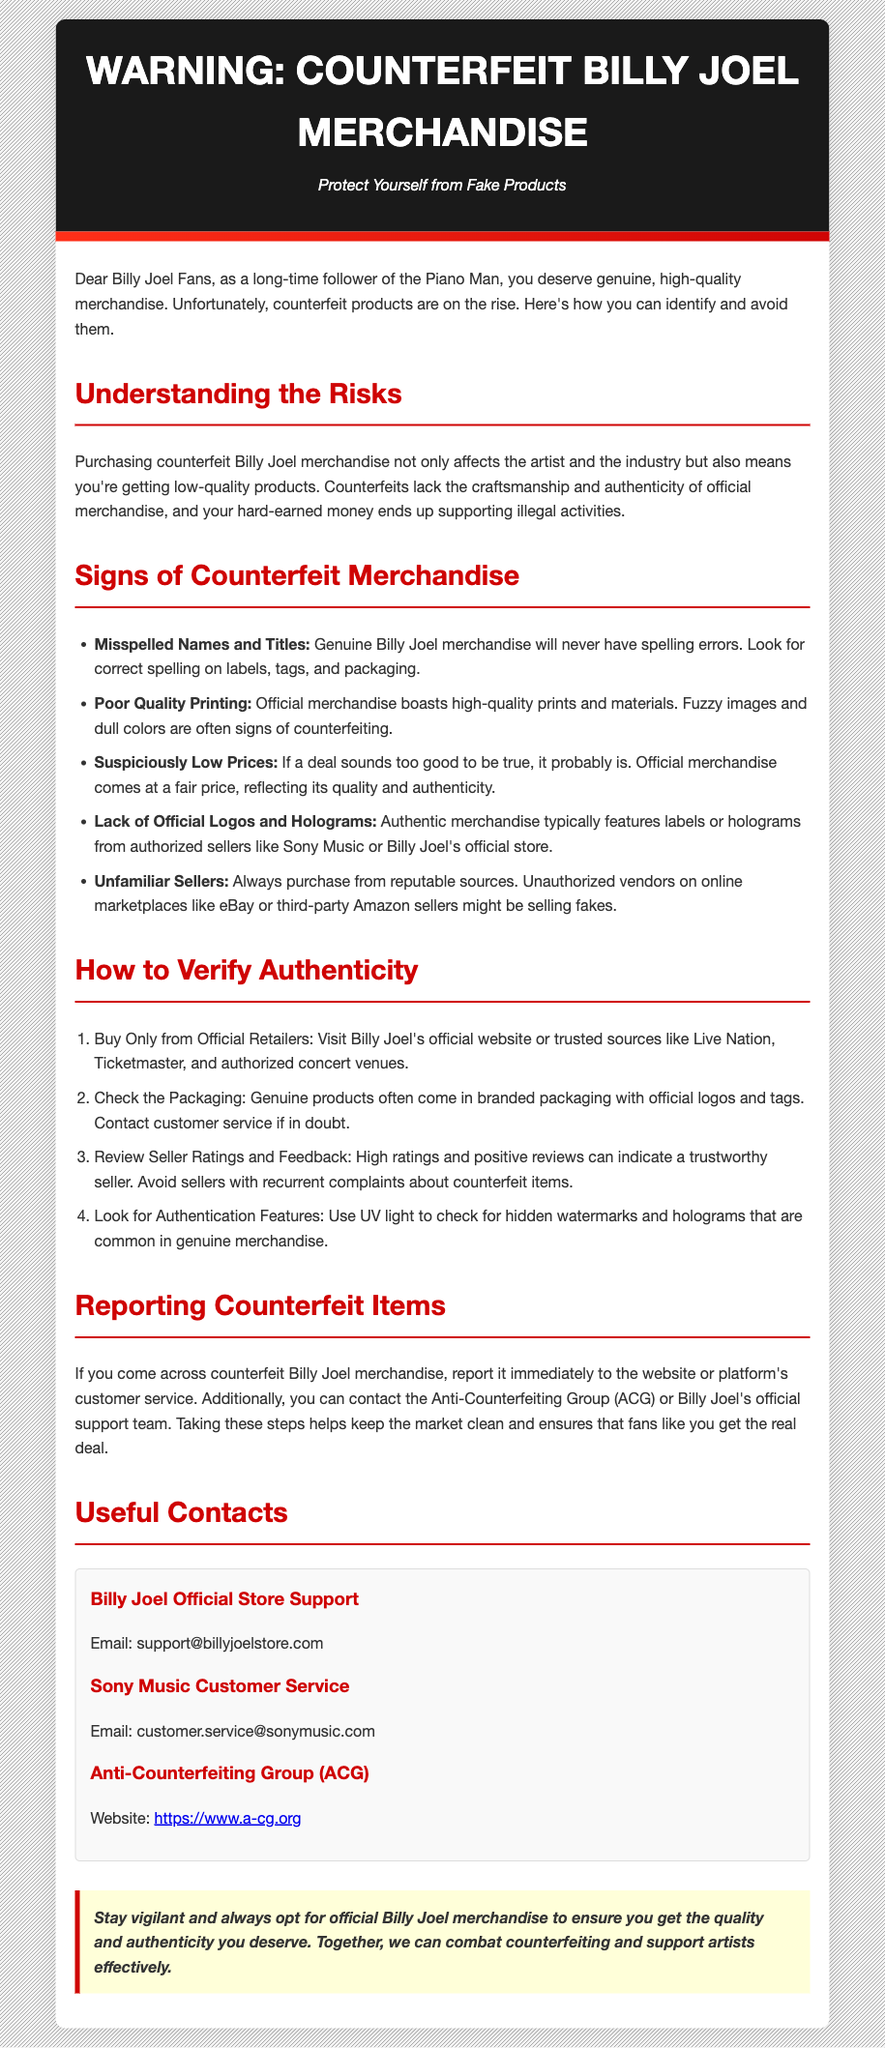What is the warning label about? The warning label informs fans about the risks and signs of purchasing counterfeit Billy Joel products.
Answer: Counterfeit Billy Joel Merchandise What should you check for on labels? Genuine Billy Joel merchandise will have correct spelling on labels, tags, and packaging.
Answer: Correct spelling What is one sign of counterfeit merchandise? One sign is poor quality prints and materials, leading to fuzzy images.
Answer: Poor Quality Printing Where can you buy authentic merchandise? You can buy from Billy Joel's official website or trusted sources like Live Nation and Ticketmaster.
Answer: Official Retailers What should you do if you find counterfeit items? You should report them immediately to the website or platform's customer service.
Answer: Report it What type of quality should official merchandise have? Official merchandise should have high-quality prints and materials, not low-quality.
Answer: High-quality What can you use to check for hidden watermarks? Use UV light to check for hidden watermarks in genuine merchandise.
Answer: UV light Which organization can you contact about counterfeiting? You can contact the Anti-Counterfeiting Group (ACG).
Answer: ACG What does the conclusion encourage fans to do? The conclusion encourages fans to always opt for official Billy Joel merchandise.
Answer: Opt for official merchandise 